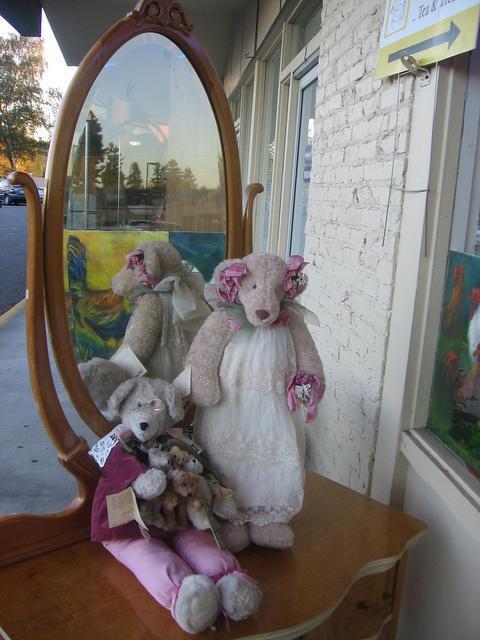How many stuffed animals are shown?
Give a very brief answer. 2. How many teddy bears are there?
Give a very brief answer. 2. 